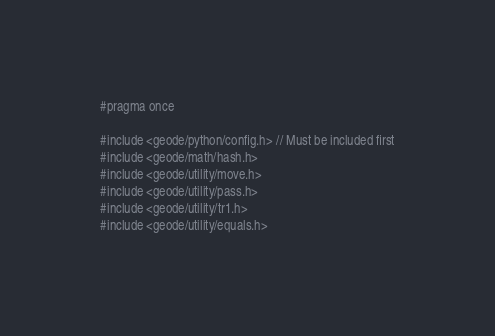<code> <loc_0><loc_0><loc_500><loc_500><_C_>#pragma once

#include <geode/python/config.h> // Must be included first
#include <geode/math/hash.h>
#include <geode/utility/move.h>
#include <geode/utility/pass.h>
#include <geode/utility/tr1.h>
#include <geode/utility/equals.h></code> 